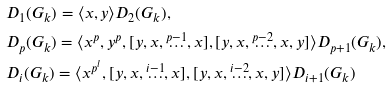Convert formula to latex. <formula><loc_0><loc_0><loc_500><loc_500>& D _ { 1 } ( G _ { k } ) = \langle x , y \rangle D _ { 2 } ( G _ { k } ) , \\ & D _ { p } ( G _ { k } ) = \langle x ^ { p } , y ^ { p } , [ y , x , \overset { p - 1 } { \dots } , x ] , [ y , x , \overset { p - 2 } { \dots } , x , y ] \rangle D _ { p + 1 } ( G _ { k } ) , \\ & D _ { i } ( G _ { k } ) = \langle x ^ { p ^ { l } } , [ y , x , \overset { i - 1 } { \dots } , x ] , [ y , x , \overset { i - 2 } { \dots } , x , y ] \rangle D _ { i + 1 } ( G _ { k } )</formula> 